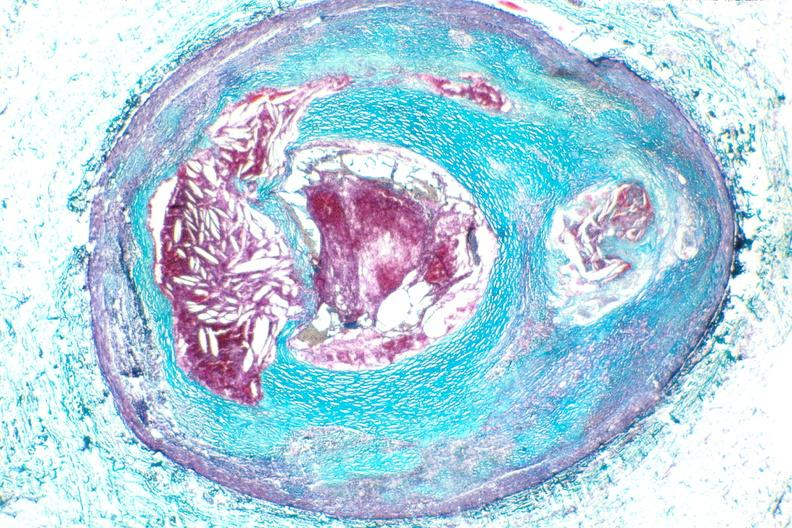s vasculature present?
Answer the question using a single word or phrase. Yes 